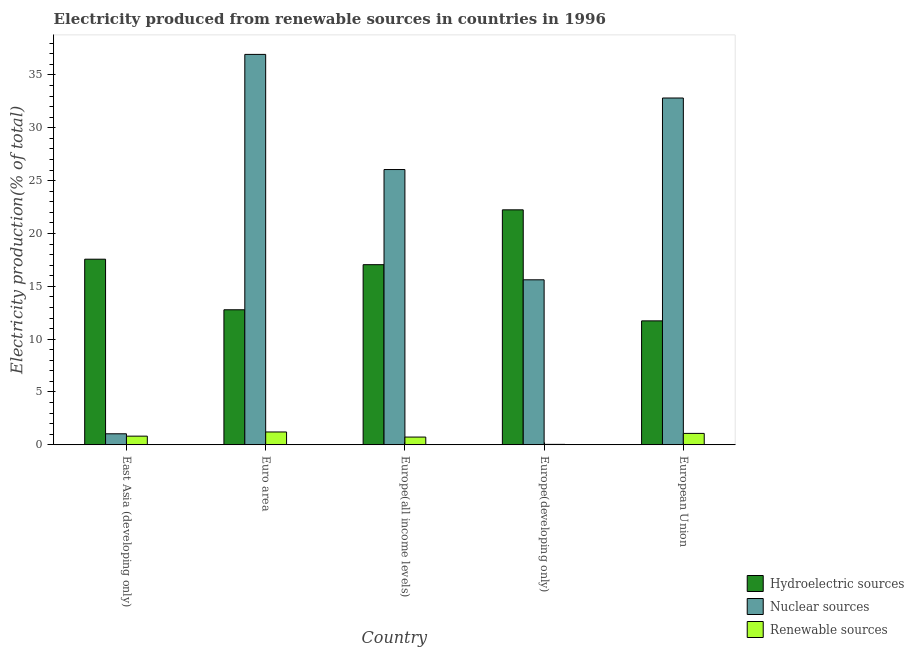How many groups of bars are there?
Offer a terse response. 5. Are the number of bars per tick equal to the number of legend labels?
Your response must be concise. Yes. How many bars are there on the 5th tick from the left?
Keep it short and to the point. 3. How many bars are there on the 1st tick from the right?
Offer a very short reply. 3. What is the label of the 1st group of bars from the left?
Make the answer very short. East Asia (developing only). In how many cases, is the number of bars for a given country not equal to the number of legend labels?
Keep it short and to the point. 0. What is the percentage of electricity produced by nuclear sources in Europe(developing only)?
Provide a short and direct response. 15.61. Across all countries, what is the maximum percentage of electricity produced by nuclear sources?
Keep it short and to the point. 36.95. Across all countries, what is the minimum percentage of electricity produced by nuclear sources?
Make the answer very short. 1.04. In which country was the percentage of electricity produced by hydroelectric sources maximum?
Ensure brevity in your answer.  Europe(developing only). In which country was the percentage of electricity produced by nuclear sources minimum?
Ensure brevity in your answer.  East Asia (developing only). What is the total percentage of electricity produced by nuclear sources in the graph?
Offer a terse response. 112.47. What is the difference between the percentage of electricity produced by hydroelectric sources in Euro area and that in Europe(developing only)?
Ensure brevity in your answer.  -9.46. What is the difference between the percentage of electricity produced by nuclear sources in East Asia (developing only) and the percentage of electricity produced by renewable sources in Europe(developing only)?
Ensure brevity in your answer.  1. What is the average percentage of electricity produced by nuclear sources per country?
Give a very brief answer. 22.49. What is the difference between the percentage of electricity produced by hydroelectric sources and percentage of electricity produced by renewable sources in East Asia (developing only)?
Your answer should be very brief. 16.75. What is the ratio of the percentage of electricity produced by nuclear sources in Euro area to that in Europe(all income levels)?
Ensure brevity in your answer.  1.42. Is the difference between the percentage of electricity produced by hydroelectric sources in East Asia (developing only) and European Union greater than the difference between the percentage of electricity produced by nuclear sources in East Asia (developing only) and European Union?
Provide a short and direct response. Yes. What is the difference between the highest and the second highest percentage of electricity produced by hydroelectric sources?
Keep it short and to the point. 4.67. What is the difference between the highest and the lowest percentage of electricity produced by hydroelectric sources?
Offer a very short reply. 10.51. In how many countries, is the percentage of electricity produced by nuclear sources greater than the average percentage of electricity produced by nuclear sources taken over all countries?
Provide a short and direct response. 3. What does the 1st bar from the left in Europe(developing only) represents?
Offer a very short reply. Hydroelectric sources. What does the 2nd bar from the right in Europe(all income levels) represents?
Provide a succinct answer. Nuclear sources. Is it the case that in every country, the sum of the percentage of electricity produced by hydroelectric sources and percentage of electricity produced by nuclear sources is greater than the percentage of electricity produced by renewable sources?
Your answer should be compact. Yes. How many countries are there in the graph?
Offer a terse response. 5. Are the values on the major ticks of Y-axis written in scientific E-notation?
Give a very brief answer. No. Does the graph contain grids?
Offer a very short reply. No. Where does the legend appear in the graph?
Give a very brief answer. Bottom right. How many legend labels are there?
Provide a short and direct response. 3. What is the title of the graph?
Offer a terse response. Electricity produced from renewable sources in countries in 1996. Does "Non-communicable diseases" appear as one of the legend labels in the graph?
Ensure brevity in your answer.  No. What is the label or title of the X-axis?
Keep it short and to the point. Country. What is the Electricity production(% of total) in Hydroelectric sources in East Asia (developing only)?
Provide a succinct answer. 17.56. What is the Electricity production(% of total) of Nuclear sources in East Asia (developing only)?
Keep it short and to the point. 1.04. What is the Electricity production(% of total) in Renewable sources in East Asia (developing only)?
Your answer should be compact. 0.82. What is the Electricity production(% of total) of Hydroelectric sources in Euro area?
Your answer should be very brief. 12.78. What is the Electricity production(% of total) of Nuclear sources in Euro area?
Your response must be concise. 36.95. What is the Electricity production(% of total) of Renewable sources in Euro area?
Make the answer very short. 1.21. What is the Electricity production(% of total) in Hydroelectric sources in Europe(all income levels)?
Your response must be concise. 17.05. What is the Electricity production(% of total) of Nuclear sources in Europe(all income levels)?
Your answer should be compact. 26.05. What is the Electricity production(% of total) in Renewable sources in Europe(all income levels)?
Give a very brief answer. 0.73. What is the Electricity production(% of total) in Hydroelectric sources in Europe(developing only)?
Keep it short and to the point. 22.24. What is the Electricity production(% of total) in Nuclear sources in Europe(developing only)?
Keep it short and to the point. 15.61. What is the Electricity production(% of total) in Renewable sources in Europe(developing only)?
Your answer should be compact. 0.04. What is the Electricity production(% of total) in Hydroelectric sources in European Union?
Make the answer very short. 11.73. What is the Electricity production(% of total) in Nuclear sources in European Union?
Ensure brevity in your answer.  32.82. What is the Electricity production(% of total) in Renewable sources in European Union?
Your answer should be compact. 1.08. Across all countries, what is the maximum Electricity production(% of total) of Hydroelectric sources?
Give a very brief answer. 22.24. Across all countries, what is the maximum Electricity production(% of total) in Nuclear sources?
Your answer should be very brief. 36.95. Across all countries, what is the maximum Electricity production(% of total) in Renewable sources?
Your answer should be compact. 1.21. Across all countries, what is the minimum Electricity production(% of total) of Hydroelectric sources?
Make the answer very short. 11.73. Across all countries, what is the minimum Electricity production(% of total) in Nuclear sources?
Provide a succinct answer. 1.04. Across all countries, what is the minimum Electricity production(% of total) of Renewable sources?
Give a very brief answer. 0.04. What is the total Electricity production(% of total) of Hydroelectric sources in the graph?
Provide a succinct answer. 81.35. What is the total Electricity production(% of total) of Nuclear sources in the graph?
Provide a succinct answer. 112.47. What is the total Electricity production(% of total) in Renewable sources in the graph?
Provide a succinct answer. 3.88. What is the difference between the Electricity production(% of total) of Hydroelectric sources in East Asia (developing only) and that in Euro area?
Offer a terse response. 4.79. What is the difference between the Electricity production(% of total) of Nuclear sources in East Asia (developing only) and that in Euro area?
Ensure brevity in your answer.  -35.91. What is the difference between the Electricity production(% of total) in Renewable sources in East Asia (developing only) and that in Euro area?
Give a very brief answer. -0.39. What is the difference between the Electricity production(% of total) in Hydroelectric sources in East Asia (developing only) and that in Europe(all income levels)?
Your answer should be very brief. 0.52. What is the difference between the Electricity production(% of total) of Nuclear sources in East Asia (developing only) and that in Europe(all income levels)?
Make the answer very short. -25.01. What is the difference between the Electricity production(% of total) in Renewable sources in East Asia (developing only) and that in Europe(all income levels)?
Keep it short and to the point. 0.09. What is the difference between the Electricity production(% of total) in Hydroelectric sources in East Asia (developing only) and that in Europe(developing only)?
Ensure brevity in your answer.  -4.67. What is the difference between the Electricity production(% of total) of Nuclear sources in East Asia (developing only) and that in Europe(developing only)?
Keep it short and to the point. -14.57. What is the difference between the Electricity production(% of total) of Renewable sources in East Asia (developing only) and that in Europe(developing only)?
Offer a very short reply. 0.78. What is the difference between the Electricity production(% of total) in Hydroelectric sources in East Asia (developing only) and that in European Union?
Provide a short and direct response. 5.84. What is the difference between the Electricity production(% of total) in Nuclear sources in East Asia (developing only) and that in European Union?
Your answer should be compact. -31.78. What is the difference between the Electricity production(% of total) of Renewable sources in East Asia (developing only) and that in European Union?
Make the answer very short. -0.26. What is the difference between the Electricity production(% of total) in Hydroelectric sources in Euro area and that in Europe(all income levels)?
Make the answer very short. -4.27. What is the difference between the Electricity production(% of total) of Nuclear sources in Euro area and that in Europe(all income levels)?
Provide a succinct answer. 10.9. What is the difference between the Electricity production(% of total) of Renewable sources in Euro area and that in Europe(all income levels)?
Make the answer very short. 0.48. What is the difference between the Electricity production(% of total) of Hydroelectric sources in Euro area and that in Europe(developing only)?
Provide a succinct answer. -9.46. What is the difference between the Electricity production(% of total) in Nuclear sources in Euro area and that in Europe(developing only)?
Your response must be concise. 21.33. What is the difference between the Electricity production(% of total) in Renewable sources in Euro area and that in Europe(developing only)?
Ensure brevity in your answer.  1.17. What is the difference between the Electricity production(% of total) of Hydroelectric sources in Euro area and that in European Union?
Give a very brief answer. 1.05. What is the difference between the Electricity production(% of total) in Nuclear sources in Euro area and that in European Union?
Make the answer very short. 4.13. What is the difference between the Electricity production(% of total) in Renewable sources in Euro area and that in European Union?
Ensure brevity in your answer.  0.13. What is the difference between the Electricity production(% of total) in Hydroelectric sources in Europe(all income levels) and that in Europe(developing only)?
Your answer should be compact. -5.19. What is the difference between the Electricity production(% of total) of Nuclear sources in Europe(all income levels) and that in Europe(developing only)?
Provide a succinct answer. 10.43. What is the difference between the Electricity production(% of total) of Renewable sources in Europe(all income levels) and that in Europe(developing only)?
Provide a short and direct response. 0.69. What is the difference between the Electricity production(% of total) in Hydroelectric sources in Europe(all income levels) and that in European Union?
Offer a terse response. 5.32. What is the difference between the Electricity production(% of total) in Nuclear sources in Europe(all income levels) and that in European Union?
Make the answer very short. -6.77. What is the difference between the Electricity production(% of total) in Renewable sources in Europe(all income levels) and that in European Union?
Keep it short and to the point. -0.35. What is the difference between the Electricity production(% of total) of Hydroelectric sources in Europe(developing only) and that in European Union?
Offer a very short reply. 10.51. What is the difference between the Electricity production(% of total) in Nuclear sources in Europe(developing only) and that in European Union?
Keep it short and to the point. -17.21. What is the difference between the Electricity production(% of total) of Renewable sources in Europe(developing only) and that in European Union?
Your answer should be compact. -1.04. What is the difference between the Electricity production(% of total) in Hydroelectric sources in East Asia (developing only) and the Electricity production(% of total) in Nuclear sources in Euro area?
Your answer should be very brief. -19.38. What is the difference between the Electricity production(% of total) of Hydroelectric sources in East Asia (developing only) and the Electricity production(% of total) of Renewable sources in Euro area?
Keep it short and to the point. 16.35. What is the difference between the Electricity production(% of total) of Nuclear sources in East Asia (developing only) and the Electricity production(% of total) of Renewable sources in Euro area?
Your answer should be compact. -0.17. What is the difference between the Electricity production(% of total) in Hydroelectric sources in East Asia (developing only) and the Electricity production(% of total) in Nuclear sources in Europe(all income levels)?
Offer a terse response. -8.48. What is the difference between the Electricity production(% of total) in Hydroelectric sources in East Asia (developing only) and the Electricity production(% of total) in Renewable sources in Europe(all income levels)?
Keep it short and to the point. 16.83. What is the difference between the Electricity production(% of total) in Nuclear sources in East Asia (developing only) and the Electricity production(% of total) in Renewable sources in Europe(all income levels)?
Your response must be concise. 0.31. What is the difference between the Electricity production(% of total) of Hydroelectric sources in East Asia (developing only) and the Electricity production(% of total) of Nuclear sources in Europe(developing only)?
Provide a succinct answer. 1.95. What is the difference between the Electricity production(% of total) of Hydroelectric sources in East Asia (developing only) and the Electricity production(% of total) of Renewable sources in Europe(developing only)?
Give a very brief answer. 17.52. What is the difference between the Electricity production(% of total) in Nuclear sources in East Asia (developing only) and the Electricity production(% of total) in Renewable sources in Europe(developing only)?
Your answer should be very brief. 1. What is the difference between the Electricity production(% of total) in Hydroelectric sources in East Asia (developing only) and the Electricity production(% of total) in Nuclear sources in European Union?
Give a very brief answer. -15.26. What is the difference between the Electricity production(% of total) in Hydroelectric sources in East Asia (developing only) and the Electricity production(% of total) in Renewable sources in European Union?
Your answer should be very brief. 16.49. What is the difference between the Electricity production(% of total) of Nuclear sources in East Asia (developing only) and the Electricity production(% of total) of Renewable sources in European Union?
Make the answer very short. -0.04. What is the difference between the Electricity production(% of total) in Hydroelectric sources in Euro area and the Electricity production(% of total) in Nuclear sources in Europe(all income levels)?
Offer a very short reply. -13.27. What is the difference between the Electricity production(% of total) of Hydroelectric sources in Euro area and the Electricity production(% of total) of Renewable sources in Europe(all income levels)?
Offer a very short reply. 12.05. What is the difference between the Electricity production(% of total) in Nuclear sources in Euro area and the Electricity production(% of total) in Renewable sources in Europe(all income levels)?
Give a very brief answer. 36.22. What is the difference between the Electricity production(% of total) of Hydroelectric sources in Euro area and the Electricity production(% of total) of Nuclear sources in Europe(developing only)?
Ensure brevity in your answer.  -2.84. What is the difference between the Electricity production(% of total) of Hydroelectric sources in Euro area and the Electricity production(% of total) of Renewable sources in Europe(developing only)?
Your answer should be very brief. 12.74. What is the difference between the Electricity production(% of total) of Nuclear sources in Euro area and the Electricity production(% of total) of Renewable sources in Europe(developing only)?
Your answer should be compact. 36.91. What is the difference between the Electricity production(% of total) of Hydroelectric sources in Euro area and the Electricity production(% of total) of Nuclear sources in European Union?
Provide a succinct answer. -20.04. What is the difference between the Electricity production(% of total) in Hydroelectric sources in Euro area and the Electricity production(% of total) in Renewable sources in European Union?
Make the answer very short. 11.7. What is the difference between the Electricity production(% of total) in Nuclear sources in Euro area and the Electricity production(% of total) in Renewable sources in European Union?
Offer a terse response. 35.87. What is the difference between the Electricity production(% of total) in Hydroelectric sources in Europe(all income levels) and the Electricity production(% of total) in Nuclear sources in Europe(developing only)?
Offer a terse response. 1.43. What is the difference between the Electricity production(% of total) of Hydroelectric sources in Europe(all income levels) and the Electricity production(% of total) of Renewable sources in Europe(developing only)?
Your answer should be compact. 17.01. What is the difference between the Electricity production(% of total) of Nuclear sources in Europe(all income levels) and the Electricity production(% of total) of Renewable sources in Europe(developing only)?
Make the answer very short. 26.01. What is the difference between the Electricity production(% of total) of Hydroelectric sources in Europe(all income levels) and the Electricity production(% of total) of Nuclear sources in European Union?
Make the answer very short. -15.78. What is the difference between the Electricity production(% of total) of Hydroelectric sources in Europe(all income levels) and the Electricity production(% of total) of Renewable sources in European Union?
Ensure brevity in your answer.  15.97. What is the difference between the Electricity production(% of total) of Nuclear sources in Europe(all income levels) and the Electricity production(% of total) of Renewable sources in European Union?
Provide a short and direct response. 24.97. What is the difference between the Electricity production(% of total) of Hydroelectric sources in Europe(developing only) and the Electricity production(% of total) of Nuclear sources in European Union?
Offer a very short reply. -10.58. What is the difference between the Electricity production(% of total) of Hydroelectric sources in Europe(developing only) and the Electricity production(% of total) of Renewable sources in European Union?
Keep it short and to the point. 21.16. What is the difference between the Electricity production(% of total) in Nuclear sources in Europe(developing only) and the Electricity production(% of total) in Renewable sources in European Union?
Your answer should be compact. 14.54. What is the average Electricity production(% of total) of Hydroelectric sources per country?
Provide a succinct answer. 16.27. What is the average Electricity production(% of total) in Nuclear sources per country?
Your response must be concise. 22.49. What is the average Electricity production(% of total) in Renewable sources per country?
Provide a short and direct response. 0.78. What is the difference between the Electricity production(% of total) of Hydroelectric sources and Electricity production(% of total) of Nuclear sources in East Asia (developing only)?
Provide a succinct answer. 16.52. What is the difference between the Electricity production(% of total) in Hydroelectric sources and Electricity production(% of total) in Renewable sources in East Asia (developing only)?
Provide a succinct answer. 16.75. What is the difference between the Electricity production(% of total) of Nuclear sources and Electricity production(% of total) of Renewable sources in East Asia (developing only)?
Your answer should be very brief. 0.22. What is the difference between the Electricity production(% of total) in Hydroelectric sources and Electricity production(% of total) in Nuclear sources in Euro area?
Your response must be concise. -24.17. What is the difference between the Electricity production(% of total) of Hydroelectric sources and Electricity production(% of total) of Renewable sources in Euro area?
Keep it short and to the point. 11.56. What is the difference between the Electricity production(% of total) of Nuclear sources and Electricity production(% of total) of Renewable sources in Euro area?
Offer a terse response. 35.73. What is the difference between the Electricity production(% of total) in Hydroelectric sources and Electricity production(% of total) in Nuclear sources in Europe(all income levels)?
Make the answer very short. -9. What is the difference between the Electricity production(% of total) in Hydroelectric sources and Electricity production(% of total) in Renewable sources in Europe(all income levels)?
Provide a succinct answer. 16.32. What is the difference between the Electricity production(% of total) of Nuclear sources and Electricity production(% of total) of Renewable sources in Europe(all income levels)?
Ensure brevity in your answer.  25.32. What is the difference between the Electricity production(% of total) of Hydroelectric sources and Electricity production(% of total) of Nuclear sources in Europe(developing only)?
Make the answer very short. 6.62. What is the difference between the Electricity production(% of total) in Hydroelectric sources and Electricity production(% of total) in Renewable sources in Europe(developing only)?
Offer a terse response. 22.2. What is the difference between the Electricity production(% of total) in Nuclear sources and Electricity production(% of total) in Renewable sources in Europe(developing only)?
Keep it short and to the point. 15.57. What is the difference between the Electricity production(% of total) of Hydroelectric sources and Electricity production(% of total) of Nuclear sources in European Union?
Offer a terse response. -21.09. What is the difference between the Electricity production(% of total) in Hydroelectric sources and Electricity production(% of total) in Renewable sources in European Union?
Keep it short and to the point. 10.65. What is the difference between the Electricity production(% of total) of Nuclear sources and Electricity production(% of total) of Renewable sources in European Union?
Provide a short and direct response. 31.74. What is the ratio of the Electricity production(% of total) of Hydroelectric sources in East Asia (developing only) to that in Euro area?
Your response must be concise. 1.37. What is the ratio of the Electricity production(% of total) of Nuclear sources in East Asia (developing only) to that in Euro area?
Ensure brevity in your answer.  0.03. What is the ratio of the Electricity production(% of total) of Renewable sources in East Asia (developing only) to that in Euro area?
Your response must be concise. 0.68. What is the ratio of the Electricity production(% of total) in Hydroelectric sources in East Asia (developing only) to that in Europe(all income levels)?
Your answer should be compact. 1.03. What is the ratio of the Electricity production(% of total) of Nuclear sources in East Asia (developing only) to that in Europe(all income levels)?
Provide a succinct answer. 0.04. What is the ratio of the Electricity production(% of total) of Renewable sources in East Asia (developing only) to that in Europe(all income levels)?
Your answer should be very brief. 1.12. What is the ratio of the Electricity production(% of total) of Hydroelectric sources in East Asia (developing only) to that in Europe(developing only)?
Give a very brief answer. 0.79. What is the ratio of the Electricity production(% of total) in Nuclear sources in East Asia (developing only) to that in Europe(developing only)?
Your response must be concise. 0.07. What is the ratio of the Electricity production(% of total) of Renewable sources in East Asia (developing only) to that in Europe(developing only)?
Give a very brief answer. 20.45. What is the ratio of the Electricity production(% of total) of Hydroelectric sources in East Asia (developing only) to that in European Union?
Offer a very short reply. 1.5. What is the ratio of the Electricity production(% of total) in Nuclear sources in East Asia (developing only) to that in European Union?
Offer a very short reply. 0.03. What is the ratio of the Electricity production(% of total) of Renewable sources in East Asia (developing only) to that in European Union?
Offer a very short reply. 0.76. What is the ratio of the Electricity production(% of total) of Hydroelectric sources in Euro area to that in Europe(all income levels)?
Provide a short and direct response. 0.75. What is the ratio of the Electricity production(% of total) of Nuclear sources in Euro area to that in Europe(all income levels)?
Provide a succinct answer. 1.42. What is the ratio of the Electricity production(% of total) of Renewable sources in Euro area to that in Europe(all income levels)?
Make the answer very short. 1.66. What is the ratio of the Electricity production(% of total) of Hydroelectric sources in Euro area to that in Europe(developing only)?
Keep it short and to the point. 0.57. What is the ratio of the Electricity production(% of total) in Nuclear sources in Euro area to that in Europe(developing only)?
Offer a terse response. 2.37. What is the ratio of the Electricity production(% of total) in Renewable sources in Euro area to that in Europe(developing only)?
Offer a very short reply. 30.3. What is the ratio of the Electricity production(% of total) of Hydroelectric sources in Euro area to that in European Union?
Ensure brevity in your answer.  1.09. What is the ratio of the Electricity production(% of total) of Nuclear sources in Euro area to that in European Union?
Provide a succinct answer. 1.13. What is the ratio of the Electricity production(% of total) of Renewable sources in Euro area to that in European Union?
Your answer should be compact. 1.12. What is the ratio of the Electricity production(% of total) of Hydroelectric sources in Europe(all income levels) to that in Europe(developing only)?
Offer a very short reply. 0.77. What is the ratio of the Electricity production(% of total) in Nuclear sources in Europe(all income levels) to that in Europe(developing only)?
Provide a short and direct response. 1.67. What is the ratio of the Electricity production(% of total) of Renewable sources in Europe(all income levels) to that in Europe(developing only)?
Provide a succinct answer. 18.24. What is the ratio of the Electricity production(% of total) of Hydroelectric sources in Europe(all income levels) to that in European Union?
Offer a very short reply. 1.45. What is the ratio of the Electricity production(% of total) of Nuclear sources in Europe(all income levels) to that in European Union?
Your answer should be very brief. 0.79. What is the ratio of the Electricity production(% of total) of Renewable sources in Europe(all income levels) to that in European Union?
Your answer should be very brief. 0.68. What is the ratio of the Electricity production(% of total) in Hydroelectric sources in Europe(developing only) to that in European Union?
Your response must be concise. 1.9. What is the ratio of the Electricity production(% of total) of Nuclear sources in Europe(developing only) to that in European Union?
Ensure brevity in your answer.  0.48. What is the ratio of the Electricity production(% of total) of Renewable sources in Europe(developing only) to that in European Union?
Ensure brevity in your answer.  0.04. What is the difference between the highest and the second highest Electricity production(% of total) in Hydroelectric sources?
Your response must be concise. 4.67. What is the difference between the highest and the second highest Electricity production(% of total) of Nuclear sources?
Offer a very short reply. 4.13. What is the difference between the highest and the second highest Electricity production(% of total) of Renewable sources?
Ensure brevity in your answer.  0.13. What is the difference between the highest and the lowest Electricity production(% of total) in Hydroelectric sources?
Offer a very short reply. 10.51. What is the difference between the highest and the lowest Electricity production(% of total) of Nuclear sources?
Offer a terse response. 35.91. What is the difference between the highest and the lowest Electricity production(% of total) in Renewable sources?
Your response must be concise. 1.17. 